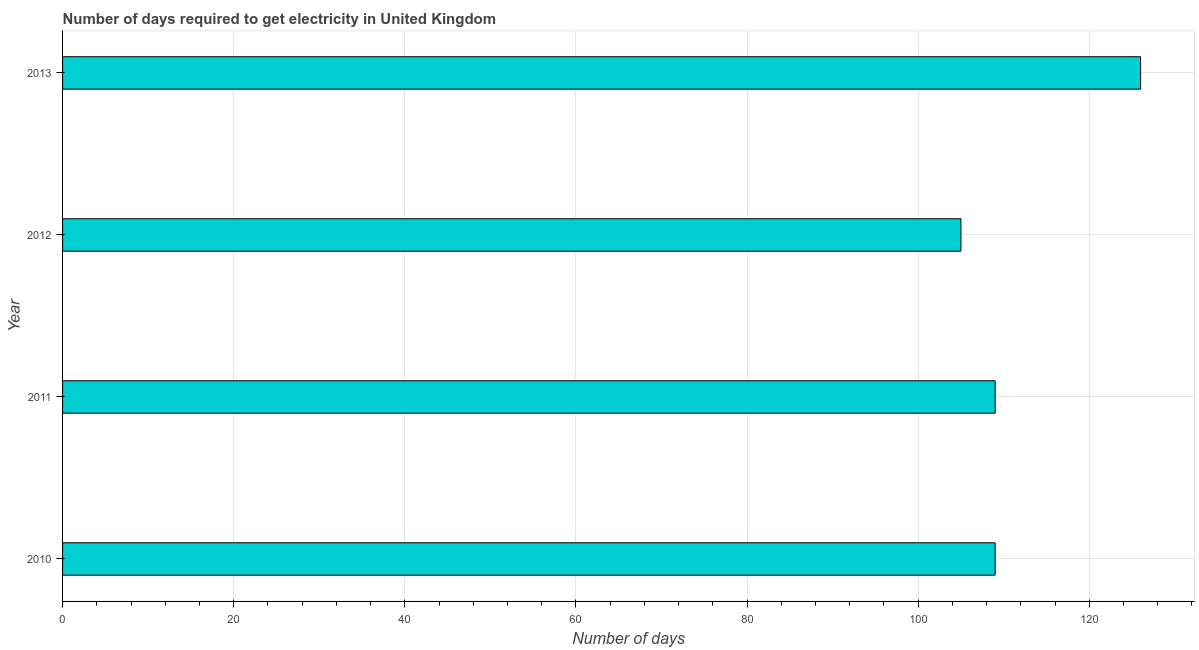Does the graph contain any zero values?
Provide a succinct answer. No. Does the graph contain grids?
Your response must be concise. Yes. What is the title of the graph?
Give a very brief answer. Number of days required to get electricity in United Kingdom. What is the label or title of the X-axis?
Ensure brevity in your answer.  Number of days. What is the label or title of the Y-axis?
Ensure brevity in your answer.  Year. What is the time to get electricity in 2012?
Offer a terse response. 105. Across all years, what is the maximum time to get electricity?
Provide a short and direct response. 126. Across all years, what is the minimum time to get electricity?
Provide a succinct answer. 105. In which year was the time to get electricity maximum?
Your answer should be very brief. 2013. In which year was the time to get electricity minimum?
Your answer should be compact. 2012. What is the sum of the time to get electricity?
Make the answer very short. 449. What is the average time to get electricity per year?
Keep it short and to the point. 112. What is the median time to get electricity?
Ensure brevity in your answer.  109. Is the difference between the time to get electricity in 2011 and 2012 greater than the difference between any two years?
Your response must be concise. No. Is the sum of the time to get electricity in 2012 and 2013 greater than the maximum time to get electricity across all years?
Keep it short and to the point. Yes. What is the difference between the highest and the lowest time to get electricity?
Keep it short and to the point. 21. In how many years, is the time to get electricity greater than the average time to get electricity taken over all years?
Offer a very short reply. 1. How many bars are there?
Your answer should be very brief. 4. How many years are there in the graph?
Your response must be concise. 4. Are the values on the major ticks of X-axis written in scientific E-notation?
Your response must be concise. No. What is the Number of days of 2010?
Your response must be concise. 109. What is the Number of days in 2011?
Offer a very short reply. 109. What is the Number of days of 2012?
Ensure brevity in your answer.  105. What is the Number of days of 2013?
Provide a succinct answer. 126. What is the difference between the Number of days in 2011 and 2013?
Make the answer very short. -17. What is the difference between the Number of days in 2012 and 2013?
Your answer should be very brief. -21. What is the ratio of the Number of days in 2010 to that in 2012?
Make the answer very short. 1.04. What is the ratio of the Number of days in 2010 to that in 2013?
Give a very brief answer. 0.86. What is the ratio of the Number of days in 2011 to that in 2012?
Keep it short and to the point. 1.04. What is the ratio of the Number of days in 2011 to that in 2013?
Offer a terse response. 0.86. What is the ratio of the Number of days in 2012 to that in 2013?
Ensure brevity in your answer.  0.83. 